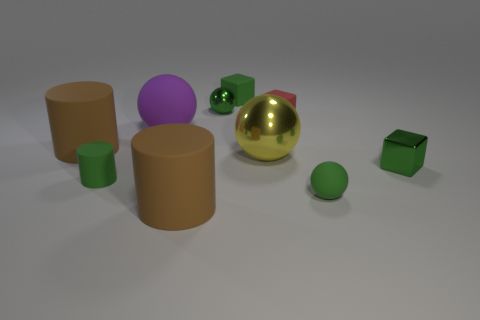What material is the tiny green cube in front of the small metallic ball?
Provide a succinct answer. Metal. Are there more tiny green matte balls that are behind the metallic block than brown matte cylinders?
Your response must be concise. No. Is there a large purple rubber ball that is in front of the tiny sphere that is on the left side of the block that is left of the yellow object?
Make the answer very short. Yes. There is a small matte ball; are there any green rubber objects in front of it?
Make the answer very short. No. What number of rubber objects have the same color as the tiny cylinder?
Your answer should be compact. 2. There is a green cube that is made of the same material as the big purple ball; what is its size?
Offer a very short reply. Small. How big is the yellow ball that is on the left side of the small green metal object that is in front of the small green shiny thing on the left side of the green matte block?
Your response must be concise. Large. There is a ball that is in front of the small green matte cylinder; what size is it?
Ensure brevity in your answer.  Small. What number of brown objects are either small balls or spheres?
Your answer should be compact. 0. Is there a yellow cylinder that has the same size as the yellow ball?
Offer a very short reply. No. 